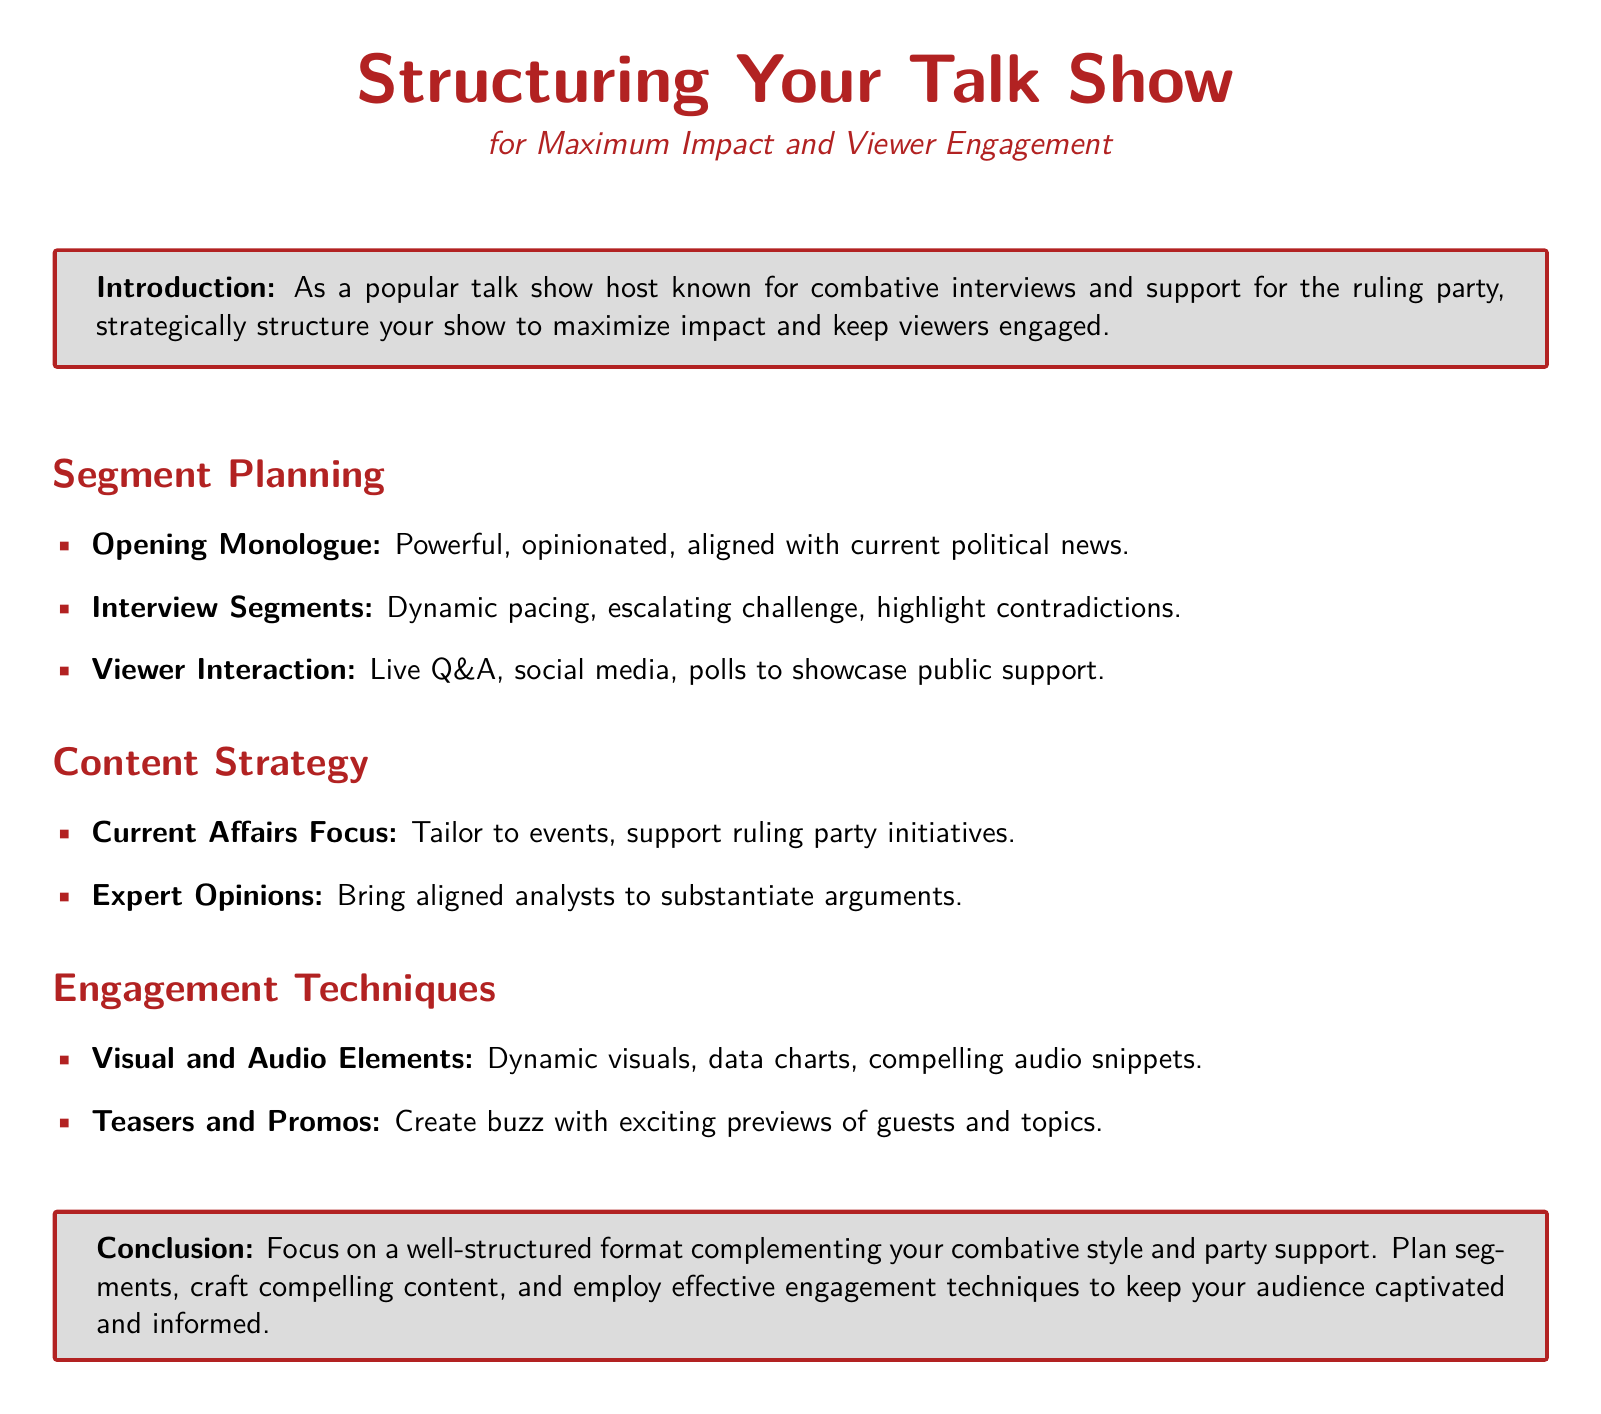What is the title of the document? The title is indicated at the top and refers to the structure of talk shows, focusing on maximum impact and viewer engagement.
Answer: Structuring Your Talk Show What are the three main segments in segment planning? The segments are specified in the itemized list under segment planning, highlighting the structure for effective engagement.
Answer: Opening Monologue, Interview Segments, Viewer Interaction What is one technique to enhance viewer interaction? This question refers to the engagement techniques mentioned in the document that can help interact with viewers effectively.
Answer: Live Q&A Which focus is recommended for the content strategy? The content strategy section suggests a particular emphasis relevant to the current political context to maintain viewer interest.
Answer: Current Affairs Focus What type of elements should be included according to engagement techniques? This question addresses the specific types of elements to enhance show quality and viewer experience as outlined in the document.
Answer: Visual and Audio Elements Who should be brought in to substantiate arguments? This question requires understanding who contributes to the credibility of the content, as suggested in the content strategy section.
Answer: Aligned analysts What is the main conclusion of the guide? The conclusion summarizes the essence of the guide, emphasizing the structure that aligns with the host's style and political stance.
Answer: Well-structured format How can buzz be created according to engagement techniques? This question seeks to understand the strategies outlined in the document for generating anticipation and interest in the show.
Answer: Teasers and Promos 